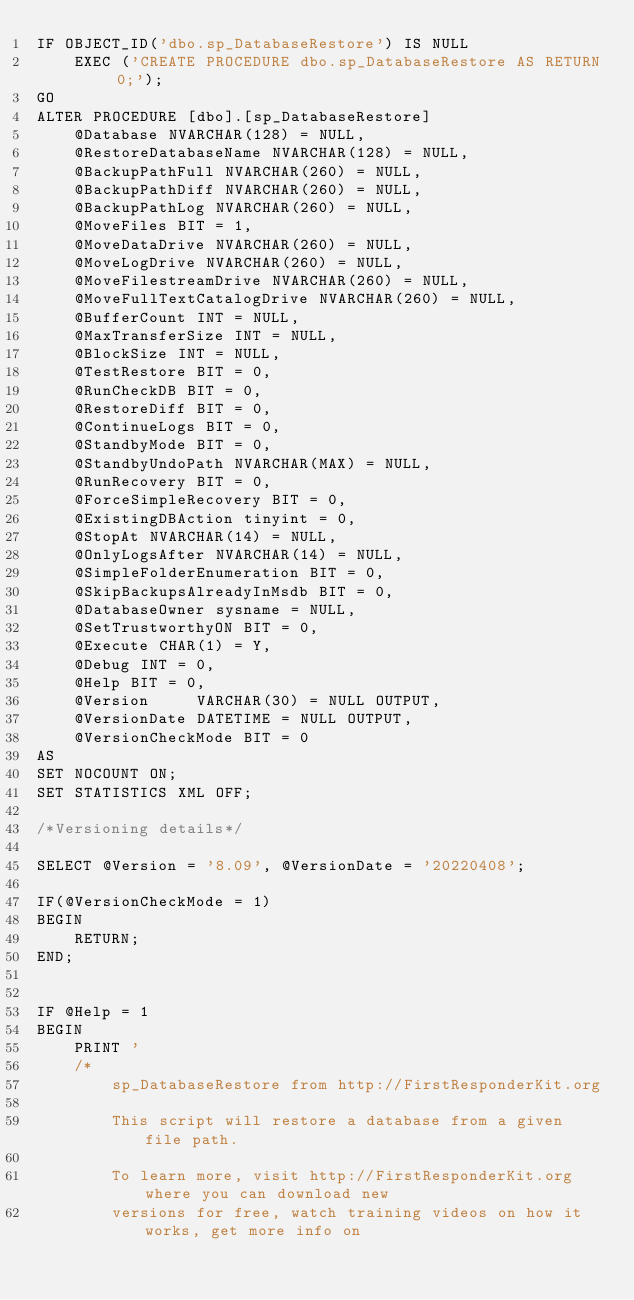Convert code to text. <code><loc_0><loc_0><loc_500><loc_500><_SQL_>IF OBJECT_ID('dbo.sp_DatabaseRestore') IS NULL
	EXEC ('CREATE PROCEDURE dbo.sp_DatabaseRestore AS RETURN 0;');
GO
ALTER PROCEDURE [dbo].[sp_DatabaseRestore]
    @Database NVARCHAR(128) = NULL, 
    @RestoreDatabaseName NVARCHAR(128) = NULL, 
    @BackupPathFull NVARCHAR(260) = NULL, 
    @BackupPathDiff NVARCHAR(260) = NULL, 
    @BackupPathLog NVARCHAR(260) = NULL,
    @MoveFiles BIT = 1, 
    @MoveDataDrive NVARCHAR(260) = NULL, 
    @MoveLogDrive NVARCHAR(260) = NULL, 
    @MoveFilestreamDrive NVARCHAR(260) = NULL,
	@MoveFullTextCatalogDrive NVARCHAR(260) = NULL, 
	@BufferCount INT = NULL,
	@MaxTransferSize INT = NULL,
	@BlockSize INT = NULL,
    @TestRestore BIT = 0, 
    @RunCheckDB BIT = 0, 
    @RestoreDiff BIT = 0,
    @ContinueLogs BIT = 0, 
    @StandbyMode BIT = 0,
    @StandbyUndoPath NVARCHAR(MAX) = NULL,
    @RunRecovery BIT = 0, 
    @ForceSimpleRecovery BIT = 0,
    @ExistingDBAction tinyint = 0,
    @StopAt NVARCHAR(14) = NULL,
    @OnlyLogsAfter NVARCHAR(14) = NULL,
    @SimpleFolderEnumeration BIT = 0,
	@SkipBackupsAlreadyInMsdb BIT = 0,
	@DatabaseOwner sysname = NULL,
	@SetTrustworthyON BIT = 0,
    @Execute CHAR(1) = Y,
    @Debug INT = 0, 
    @Help BIT = 0,
    @Version     VARCHAR(30) = NULL OUTPUT,
	@VersionDate DATETIME = NULL OUTPUT,
    @VersionCheckMode BIT = 0
AS
SET NOCOUNT ON;
SET STATISTICS XML OFF;

/*Versioning details*/

SELECT @Version = '8.09', @VersionDate = '20220408';

IF(@VersionCheckMode = 1)
BEGIN
	RETURN;
END;

 
IF @Help = 1
BEGIN
	PRINT '
	/*
		sp_DatabaseRestore from http://FirstResponderKit.org
			
		This script will restore a database from a given file path.
		
		To learn more, visit http://FirstResponderKit.org where you can download new
		versions for free, watch training videos on how it works, get more info on</code> 